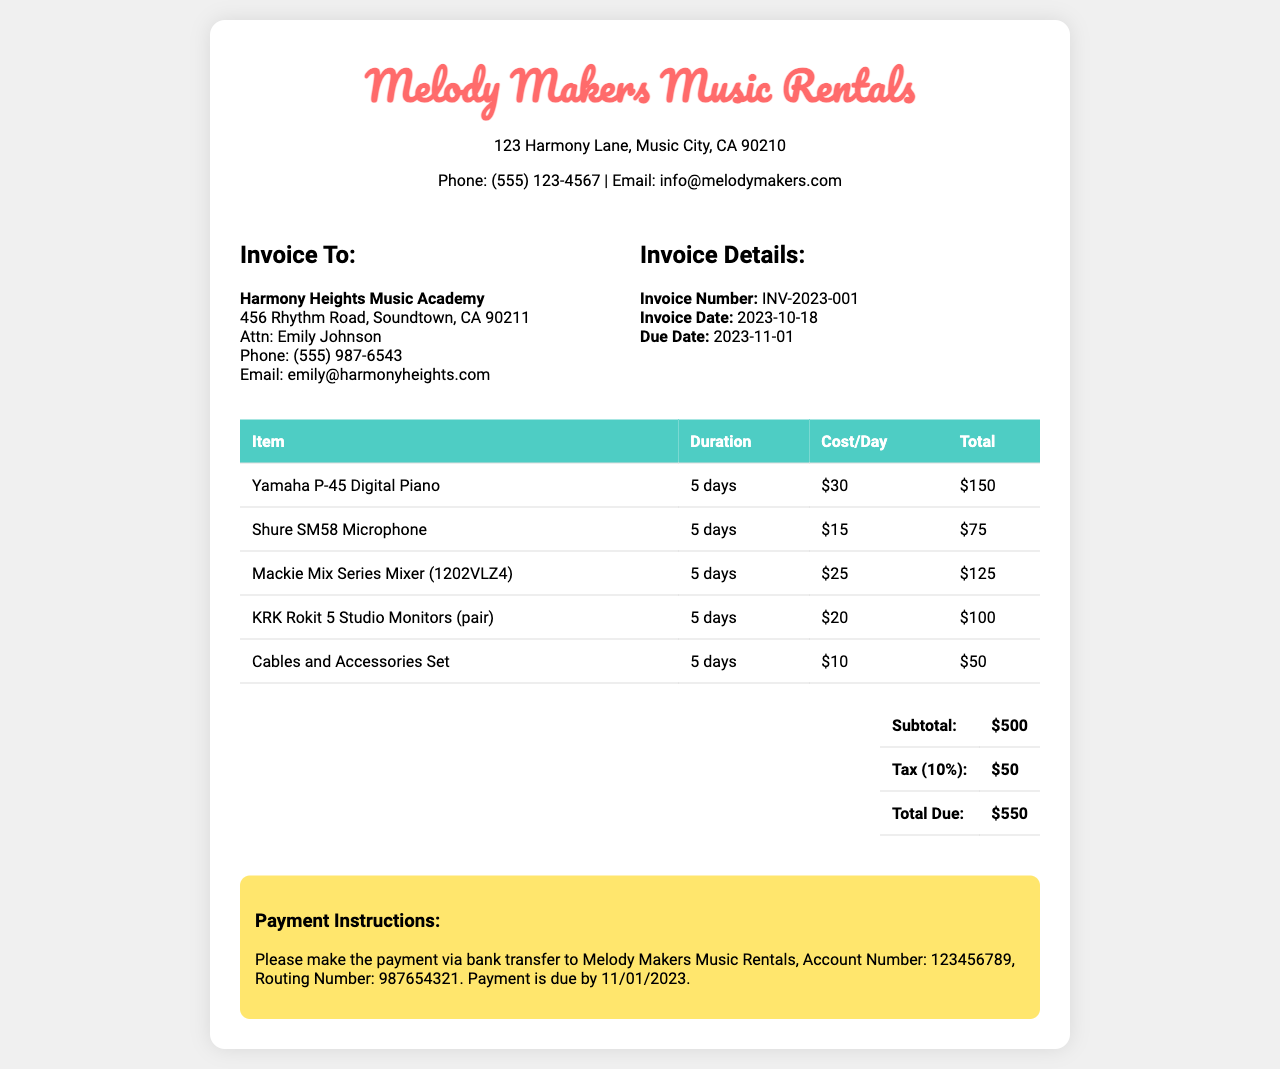What is the invoice number? The invoice number can be found in the invoice details section and is labeled as "Invoice Number."
Answer: INV-2023-001 What is the due date for payment? The due date is specified in the invoice details section under "Due Date."
Answer: 2023-11-01 How many days is the equipment rented for? The rental duration is indicated in each item in the table and is consistently stated as 5 days.
Answer: 5 days What is the subtotal amount? The subtotal can be located in the total section of the invoice and is labeled as "Subtotal."
Answer: $500 What is the total amount due? The total due amount is the final amount listed in the total section, marked as "Total Due."
Answer: $550 Who is the contact person at the Harmony Heights Music Academy? The contact person is named in the invoice section labeled "Invoice To."
Answer: Emily Johnson What items are included in the rental? The items can be found listed in the main table of the invoice; they include a digital piano, microphone, mixer, monitors, and cables.
Answer: Yamaha P-45 Digital Piano, Shure SM58 Microphone, Mackie Mix Series Mixer, KRK Rokit 5 Studio Monitors, Cables and Accessories Set What is the tax rate listed on the invoice? The tax information is present in the total section, marked as "Tax."
Answer: 10% What are the payment instructions for the invoice? The payment instructions can be found near the bottom of the invoice; they specify the payment method and account details.
Answer: Bank transfer to Melody Makers Music Rentals, Account Number: 123456789, Routing Number: 987654321 